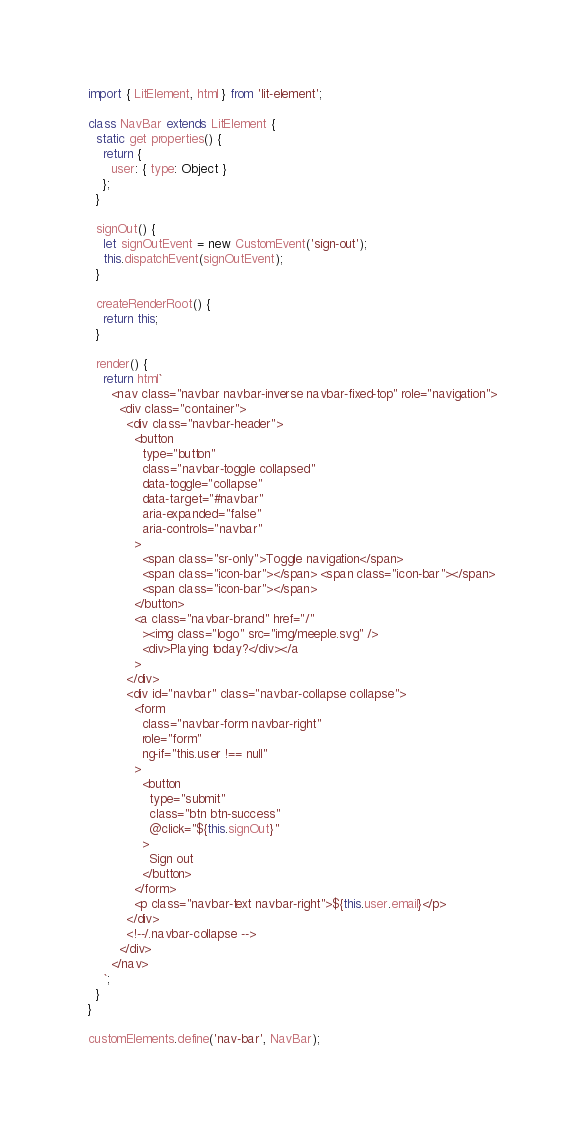Convert code to text. <code><loc_0><loc_0><loc_500><loc_500><_JavaScript_>import { LitElement, html } from 'lit-element';

class NavBar extends LitElement {
  static get properties() {
    return {
      user: { type: Object }
    };
  }

  signOut() {
    let signOutEvent = new CustomEvent('sign-out');
    this.dispatchEvent(signOutEvent);
  }

  createRenderRoot() {
    return this;
  }

  render() {
    return html`
      <nav class="navbar navbar-inverse navbar-fixed-top" role="navigation">
        <div class="container">
          <div class="navbar-header">
            <button
              type="button"
              class="navbar-toggle collapsed"
              data-toggle="collapse"
              data-target="#navbar"
              aria-expanded="false"
              aria-controls="navbar"
            >
              <span class="sr-only">Toggle navigation</span>
              <span class="icon-bar"></span> <span class="icon-bar"></span>
              <span class="icon-bar"></span>
            </button>
            <a class="navbar-brand" href="/"
              ><img class="logo" src="img/meeple.svg" />
              <div>Playing today?</div></a
            >
          </div>
          <div id="navbar" class="navbar-collapse collapse">
            <form
              class="navbar-form navbar-right"
              role="form"
              ng-if="this.user !== null"
            >
              <button
                type="submit"
                class="btn btn-success"
                @click="${this.signOut}"
              >
                Sign out
              </button>
            </form>
            <p class="navbar-text navbar-right">${this.user.email}</p>
          </div>
          <!--/.navbar-collapse -->
        </div>
      </nav>
    `;
  }
}

customElements.define('nav-bar', NavBar);
</code> 